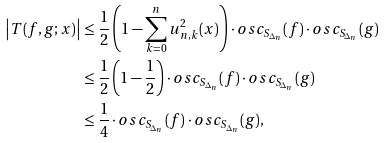Convert formula to latex. <formula><loc_0><loc_0><loc_500><loc_500>\left | T ( f , g ; x ) \right | & \leq \frac { 1 } { 2 } \left ( 1 - \sum ^ { n } _ { k = 0 } { u ^ { 2 } _ { n , k } ( x ) } \right ) \cdot o s c _ { S _ { \Delta _ { n } } } ( f ) \cdot o s c _ { S _ { \Delta _ { n } } } ( g ) \\ & \leq \frac { 1 } { 2 } \left ( 1 - \frac { 1 } { 2 } \right ) \cdot o s c _ { S _ { \Delta _ { n } } } ( f ) \cdot o s c _ { S _ { \Delta _ { n } } } ( g ) \\ & \leq \frac { 1 } { 4 } \cdot o s c _ { S _ { \Delta _ { n } } } ( f ) \cdot o s c _ { S _ { \Delta _ { n } } } ( g ) ,</formula> 